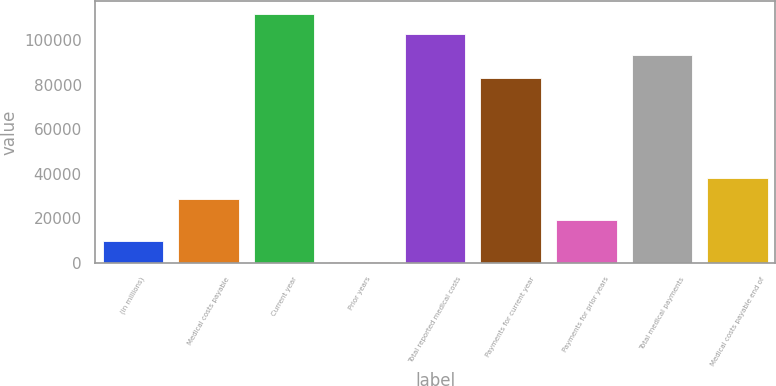Convert chart to OTSL. <chart><loc_0><loc_0><loc_500><loc_500><bar_chart><fcel>(in millions)<fcel>Medical costs payable<fcel>Current year<fcel>Prior years<fcel>Total reported medical costs<fcel>Payments for current year<fcel>Payments for prior years<fcel>Total medical payments<fcel>Medical costs payable end of<nl><fcel>9783.3<fcel>28509.9<fcel>111895<fcel>420<fcel>102531<fcel>82750<fcel>19146.6<fcel>93168<fcel>37873.2<nl></chart> 